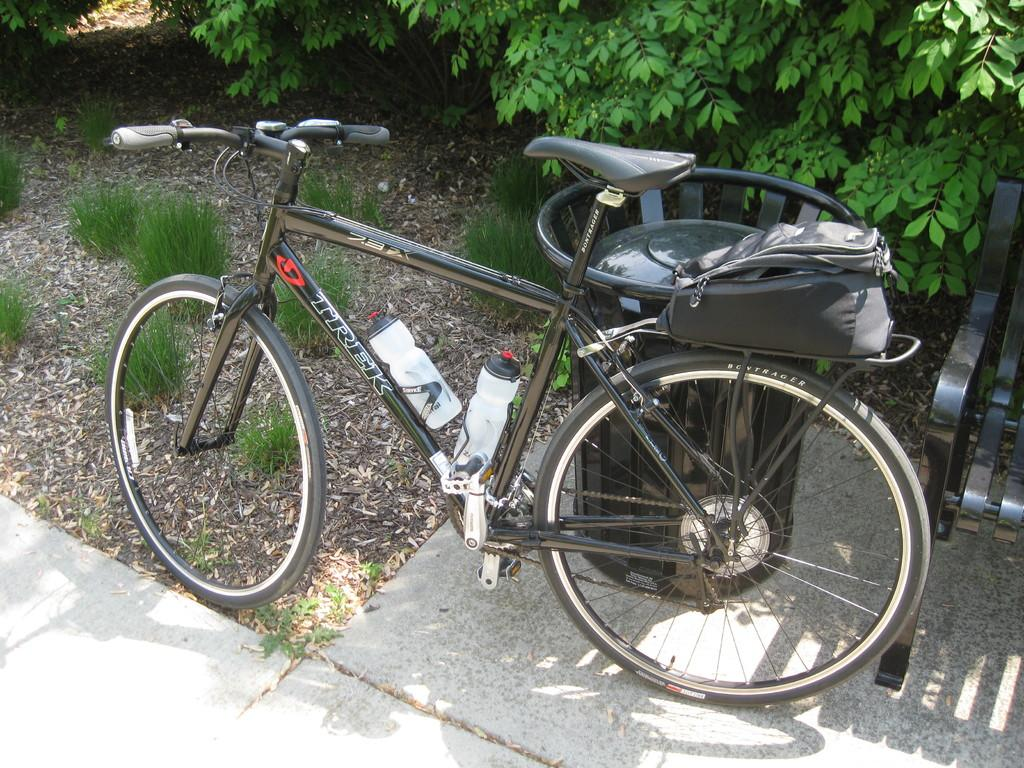What is the main object in the image? There is a bicycle in the image. Where is the bicycle located? The bicycle is parked near a footpath. What other objects can be seen on the footpath? There is a bench and a dustbin on the footpath. What can be seen in the background of the image? There are trees and grass in the background of the image. What type of trail can be seen in the image? There is no trail visible in the image; it features a bicycle parked near a footpath with trees and grass in the background. 